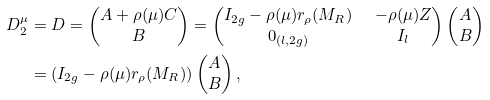Convert formula to latex. <formula><loc_0><loc_0><loc_500><loc_500>D _ { 2 } ^ { \mu } & = D = \begin{pmatrix} A + \rho ( \mu ) C \\ B \end{pmatrix} = \begin{pmatrix} I _ { 2 g } - \rho ( \mu ) r _ { \rho } ( M _ { R } ) & \ - \rho ( \mu ) Z \\ 0 _ { ( l , 2 g ) } & \ I _ { l } \end{pmatrix} \begin{pmatrix} A \\ B \end{pmatrix} \\ & = ( I _ { 2 g } - \rho ( \mu ) r _ { \rho } ( M _ { R } ) ) \begin{pmatrix} A \\ B \end{pmatrix} ,</formula> 